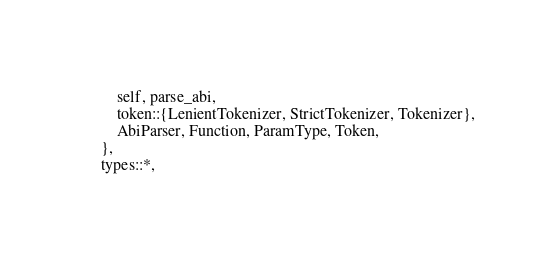Convert code to text. <code><loc_0><loc_0><loc_500><loc_500><_Rust_>        self, parse_abi,
        token::{LenientTokenizer, StrictTokenizer, Tokenizer},
        AbiParser, Function, ParamType, Token,
    },
    types::*,</code> 